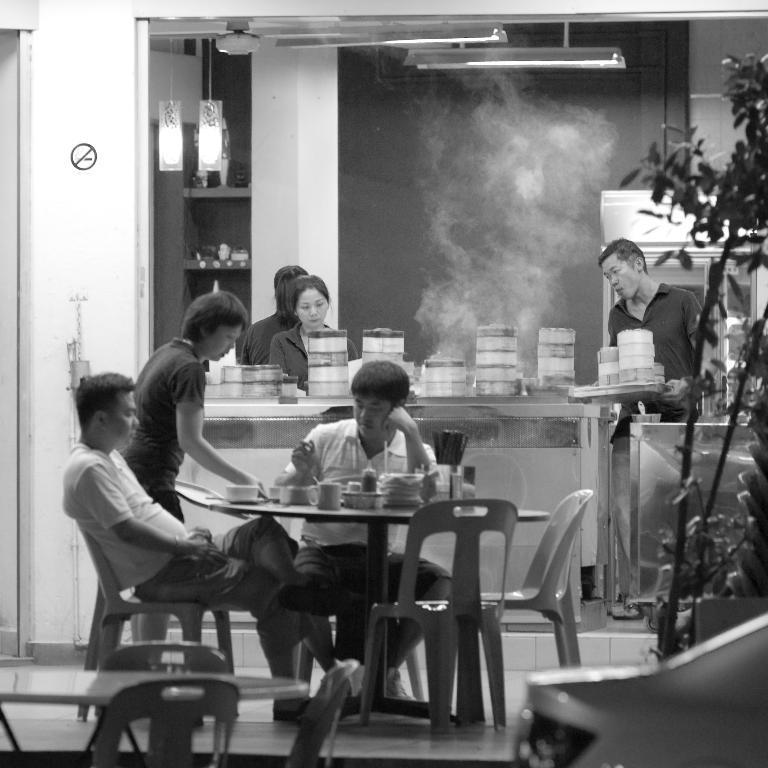Could you give a brief overview of what you see in this image? In this picture there are two men who are sitting on the chair. There is a cup, sticks and few objects on the table. There is a person standing. There are two women who are standing. There are boxes on the desk. There is a man standing and holding few boxes in a tray. There is a bowl ,spoon on the table. There lights, smoke, plant. 